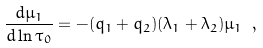<formula> <loc_0><loc_0><loc_500><loc_500>\frac { d \mu _ { 1 } } { d \ln { \tau _ { 0 } } } = - ( q _ { 1 } + q _ { 2 } ) ( \lambda _ { 1 } + \lambda _ { 2 } ) \mu _ { 1 } \ ,</formula> 